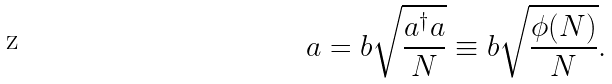<formula> <loc_0><loc_0><loc_500><loc_500>a = b \sqrt { \frac { a ^ { \dagger } a } { N } } \equiv b \sqrt { \frac { \phi ( N ) } { N } } .</formula> 